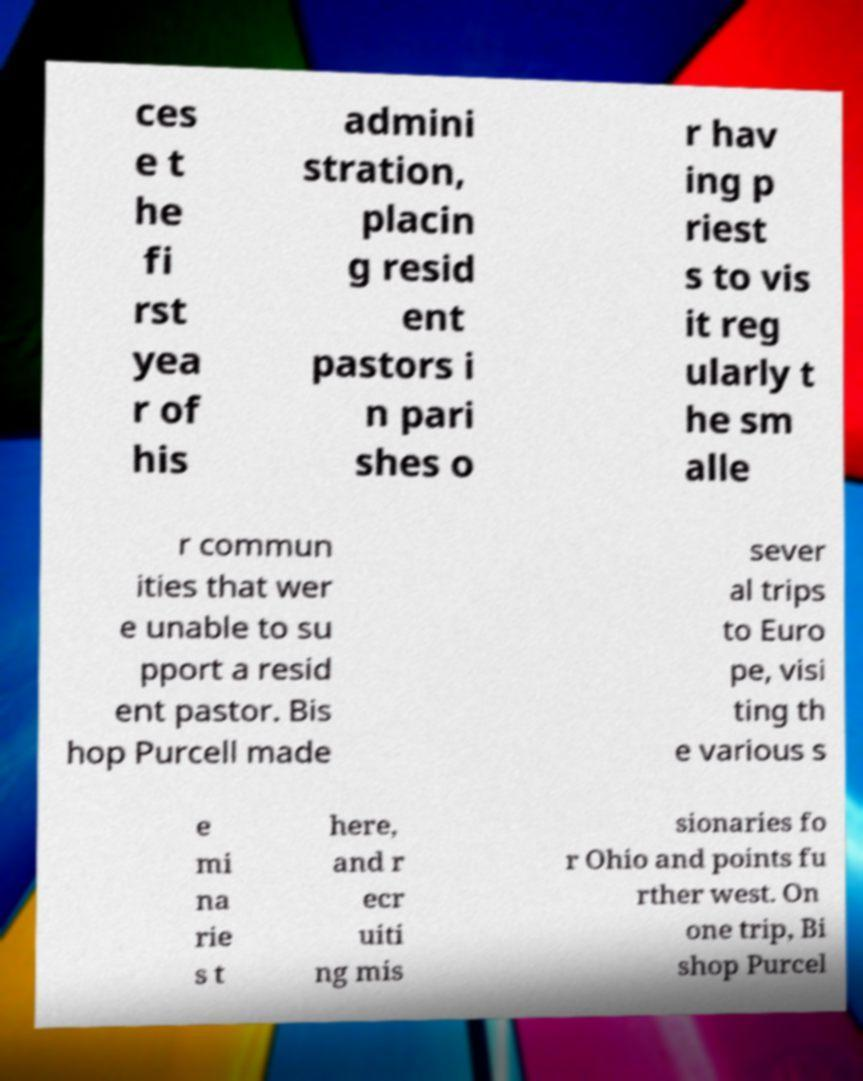Could you assist in decoding the text presented in this image and type it out clearly? ces e t he fi rst yea r of his admini stration, placin g resid ent pastors i n pari shes o r hav ing p riest s to vis it reg ularly t he sm alle r commun ities that wer e unable to su pport a resid ent pastor. Bis hop Purcell made sever al trips to Euro pe, visi ting th e various s e mi na rie s t here, and r ecr uiti ng mis sionaries fo r Ohio and points fu rther west. On one trip, Bi shop Purcel 